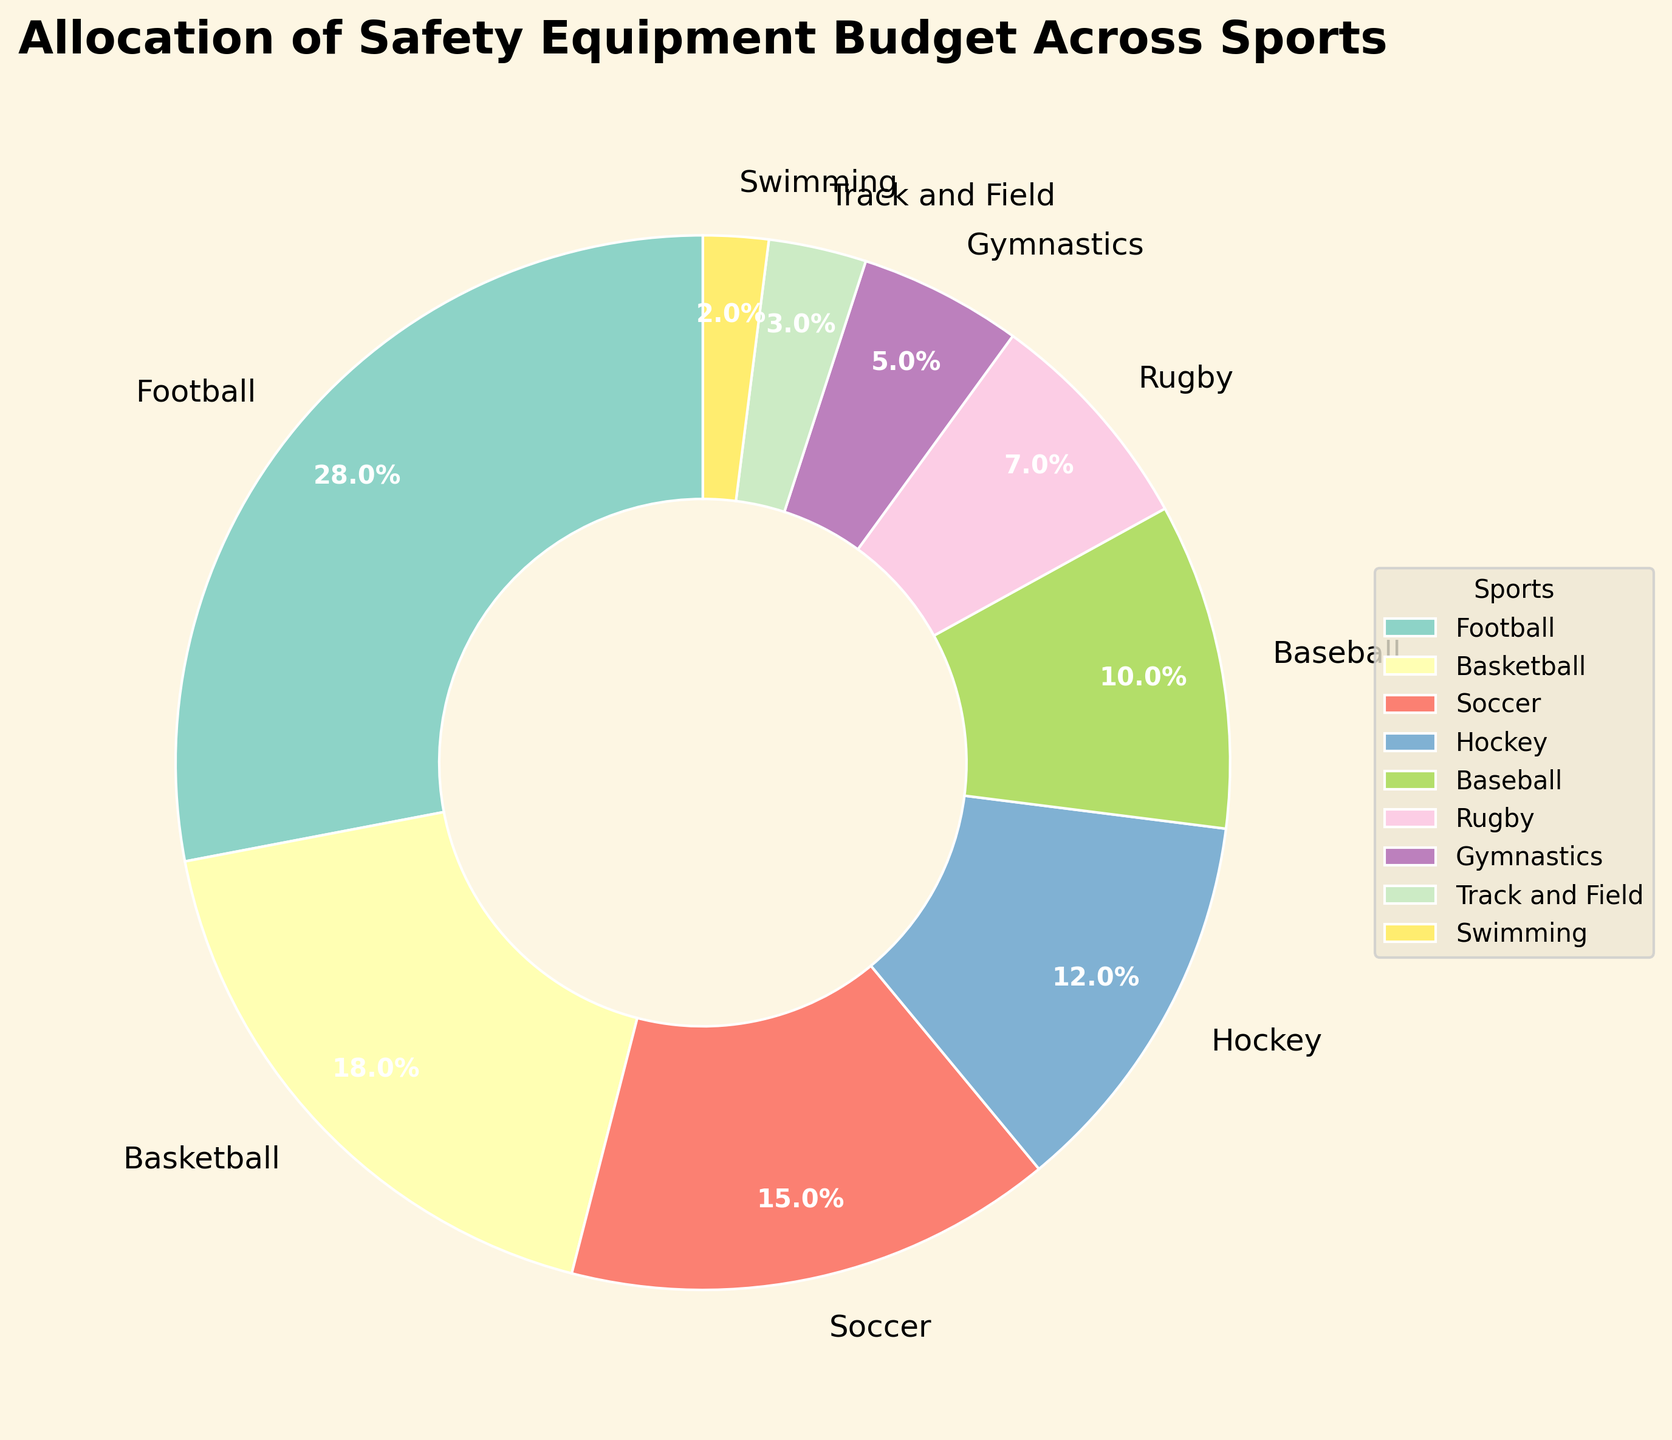Which sport receives the highest budget allocation percentage? The sport with the largest portion of the pie chart represents the highest budget allocation percentage. In the chart, it's the one labeled with the largest percentage.
Answer: Football Which sport receives less budget allocation than Soccer but more than Gymnastics? By examining the pie chart, identify the percentages assigned to Soccer and Gymnastics. The sport between these two percentages is the answer.
Answer: Hockey How much more is budgeted for Football than Rugby? Subtract Rugby's percentage (7%) from Football's percentage (28%).
Answer: 21% Which two sports combined receive the same budget allocation percentage as Football alone? Add percentages of different pairs of sports to find the combination that sums to 28%.
Answer: Basketball and Soccer Which sport has the smallest budget allocation? Look for the smallest section (or slice) of the pie chart and note its label.
Answer: Swimming How does the budget allocation for Basketball compare to that for Hockey? Compare the percentages for Basketball (18%) and Hockey (12%). Basketball's percentage is higher.
Answer: Basketball has a higher allocation than Hockey What is the total percentage of the budget allocated to Soccer, Hockey, and Baseball combined? Add the percentages for Soccer (15%), Hockey (12%), and Baseball (10%).
Answer: 37% If we were to increase Swimming’s budget by 3%, how would its allocation compare to Track and Field? Add 3% to Swimming's current percentage (2%), resulting in 5%, which equals Track and Field's allocation.
Answer: Equal What percentage of the budget is allocated to sports other than Football and Basketball? Subtract the sum of Football (28%) and Basketball’s (18%) allocations from 100%.
Answer: 54% How does the width of the pie slices visually indicate the budget allocation? The width of a pie slice corresponds to the percentage of the budget allocated to each sport, with wider slices indicating a higher percentage.
Answer: Wider slices indicate a higher budget allocation 